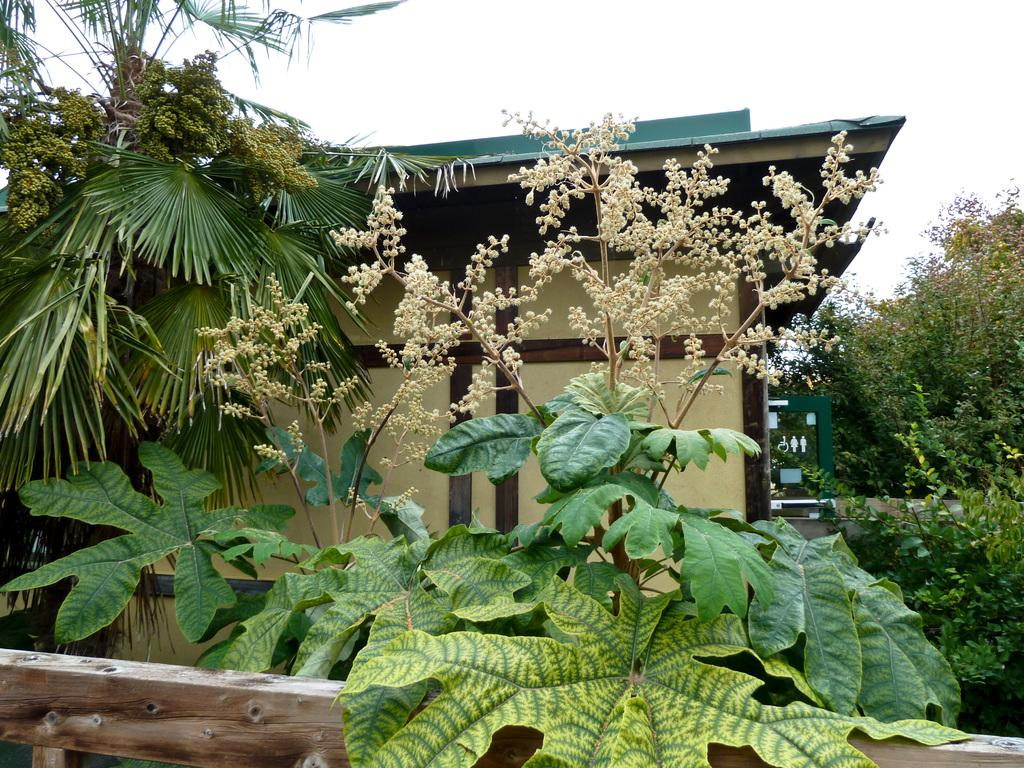What can be seen in the front side of the image? There are objects in the front side of the image. What is the color of the house shed in the background? The house shed in the background is yellow in color. What is the color of the sky in the image? The sky is blue in color. What language is spoken by the objects in the front side of the image? Objects do not speak languages, so this question cannot be answered. How does the yellow-colored house shed compare to the blue sky in the image? This question is not relevant to the image, as it does not involve any comparison between the house shed and the sky. 